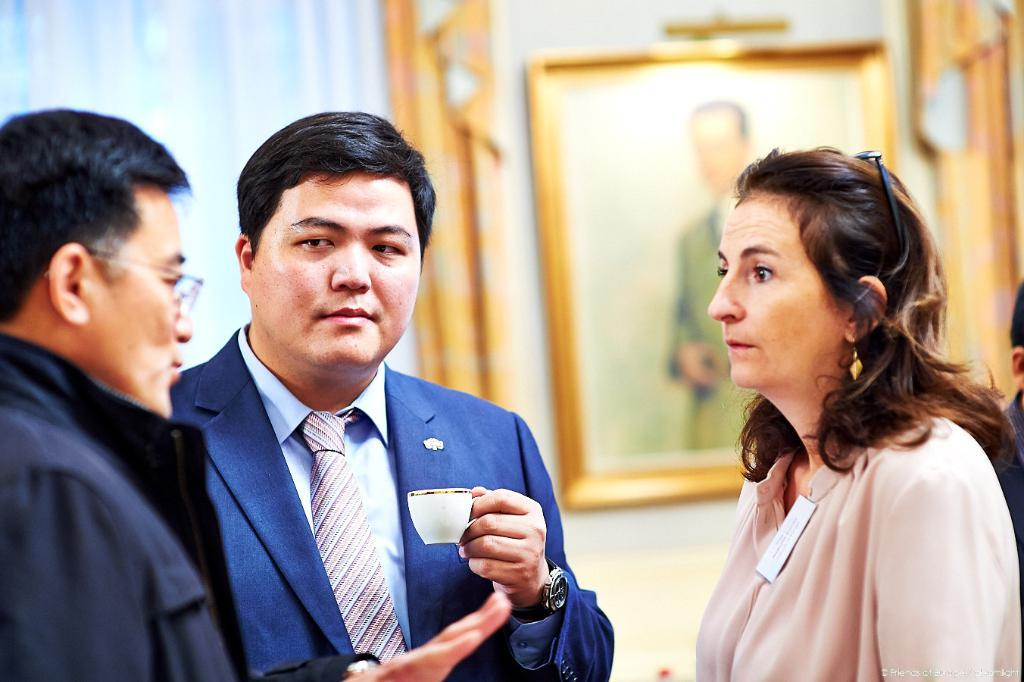What are the people in the image wearing? The persons in the image are wearing clothes. Can you describe the action of the person in the middle of the image? The person in the middle of the image is holding a cup with his hand. What can be seen on the wall in the image? There is a photo frame on the wall in the image. What type of nut is being used to hold the photo frame on the wall? There is no nut present in the image, and the photo frame is not being held by any nut. Can you describe the van that is parked in front of the persons in the image? There is no van present in the image; it only features persons wearing clothes and a photo frame on the wall. 